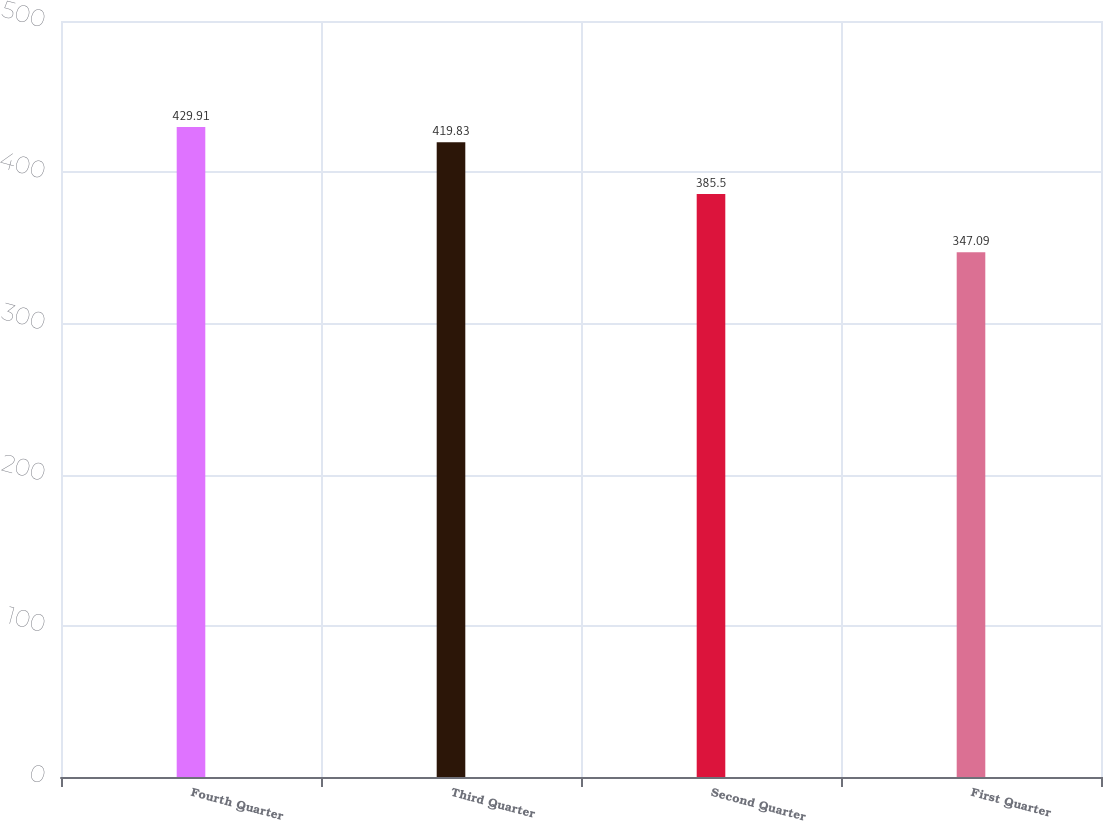Convert chart. <chart><loc_0><loc_0><loc_500><loc_500><bar_chart><fcel>Fourth Quarter<fcel>Third Quarter<fcel>Second Quarter<fcel>First Quarter<nl><fcel>429.91<fcel>419.83<fcel>385.5<fcel>347.09<nl></chart> 